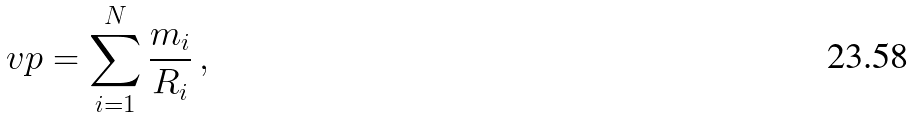Convert formula to latex. <formula><loc_0><loc_0><loc_500><loc_500>\ v p = \sum ^ { N } _ { i = 1 } \frac { m _ { i } } { R _ { i } } \, ,</formula> 